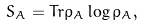Convert formula to latex. <formula><loc_0><loc_0><loc_500><loc_500>S _ { A } = T r \rho _ { A } \log \rho _ { A } ,</formula> 